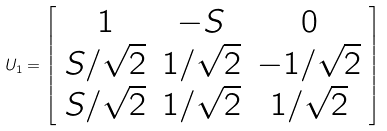<formula> <loc_0><loc_0><loc_500><loc_500>U _ { 1 } = \left [ \begin{array} { c c c } 1 & - S & 0 \\ S / \sqrt { 2 } & 1 / \sqrt { 2 } & - 1 / \sqrt { 2 } \\ S / \sqrt { 2 } & 1 / \sqrt { 2 } & 1 / \sqrt { 2 } \end{array} \right ]</formula> 